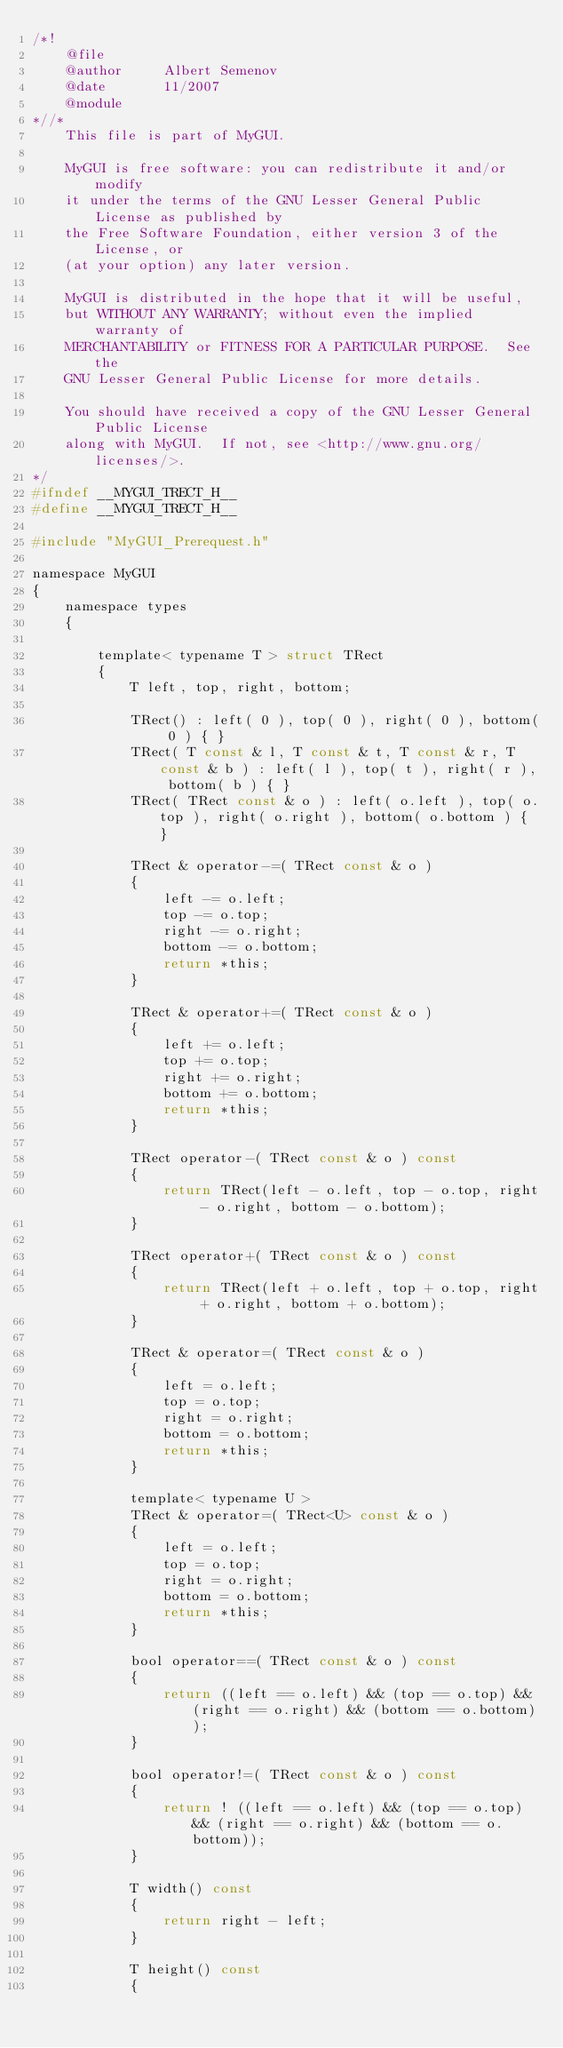Convert code to text. <code><loc_0><loc_0><loc_500><loc_500><_C_>/*!
	@file
	@author		Albert Semenov
	@date		11/2007
	@module
*//*
	This file is part of MyGUI.
	
	MyGUI is free software: you can redistribute it and/or modify
	it under the terms of the GNU Lesser General Public License as published by
	the Free Software Foundation, either version 3 of the License, or
	(at your option) any later version.
	
	MyGUI is distributed in the hope that it will be useful,
	but WITHOUT ANY WARRANTY; without even the implied warranty of
	MERCHANTABILITY or FITNESS FOR A PARTICULAR PURPOSE.  See the
	GNU Lesser General Public License for more details.
	
	You should have received a copy of the GNU Lesser General Public License
	along with MyGUI.  If not, see <http://www.gnu.org/licenses/>.
*/
#ifndef __MYGUI_TRECT_H__
#define __MYGUI_TRECT_H__

#include "MyGUI_Prerequest.h"

namespace MyGUI
{
	namespace types
	{

		template< typename T > struct TRect
		{
			T left, top, right, bottom;

			TRect() : left( 0 ), top( 0 ), right( 0 ), bottom( 0 ) { }
			TRect( T const & l, T const & t, T const & r, T const & b ) : left( l ), top( t ), right( r ), bottom( b ) { }
			TRect( TRect const & o ) : left( o.left ), top( o.top ), right( o.right ), bottom( o.bottom ) { }

			TRect & operator-=( TRect const & o )
			{
				left -= o.left;
				top -= o.top;
				right -= o.right;
				bottom -= o.bottom;
				return *this;
			}

			TRect & operator+=( TRect const & o )
			{
				left += o.left;
				top += o.top;
				right += o.right;
				bottom += o.bottom;
				return *this;
			}

			TRect operator-( TRect const & o ) const
			{
				return TRect(left - o.left, top - o.top, right - o.right, bottom - o.bottom);
			}

			TRect operator+( TRect const & o ) const
			{
				return TRect(left + o.left, top + o.top, right + o.right, bottom + o.bottom);
			}

			TRect & operator=( TRect const & o )
			{
				left = o.left;
				top = o.top;
				right = o.right;
				bottom = o.bottom;
				return *this;
			}

			template< typename U >
			TRect & operator=( TRect<U> const & o )
			{
				left = o.left;
				top = o.top;
				right = o.right;
				bottom = o.bottom;
				return *this;
			}

			bool operator==( TRect const & o ) const
			{
				return ((left == o.left) && (top == o.top) && (right == o.right) && (bottom == o.bottom));
			}

			bool operator!=( TRect const & o ) const
			{
				return ! ((left == o.left) && (top == o.top) && (right == o.right) && (bottom == o.bottom));
			}

			T width() const
			{
				return right - left;
			}

			T height() const
			{</code> 